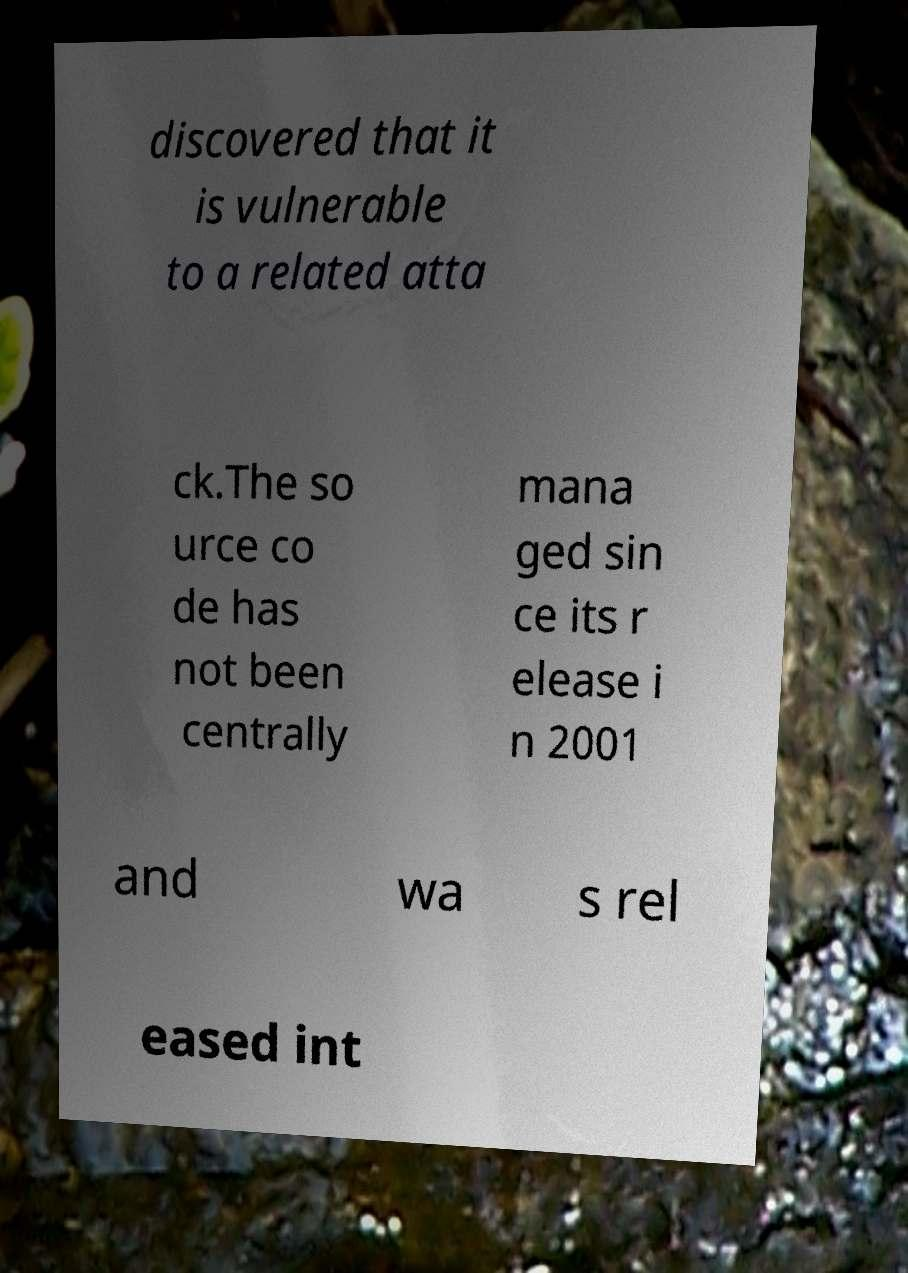Please read and relay the text visible in this image. What does it say? discovered that it is vulnerable to a related atta ck.The so urce co de has not been centrally mana ged sin ce its r elease i n 2001 and wa s rel eased int 